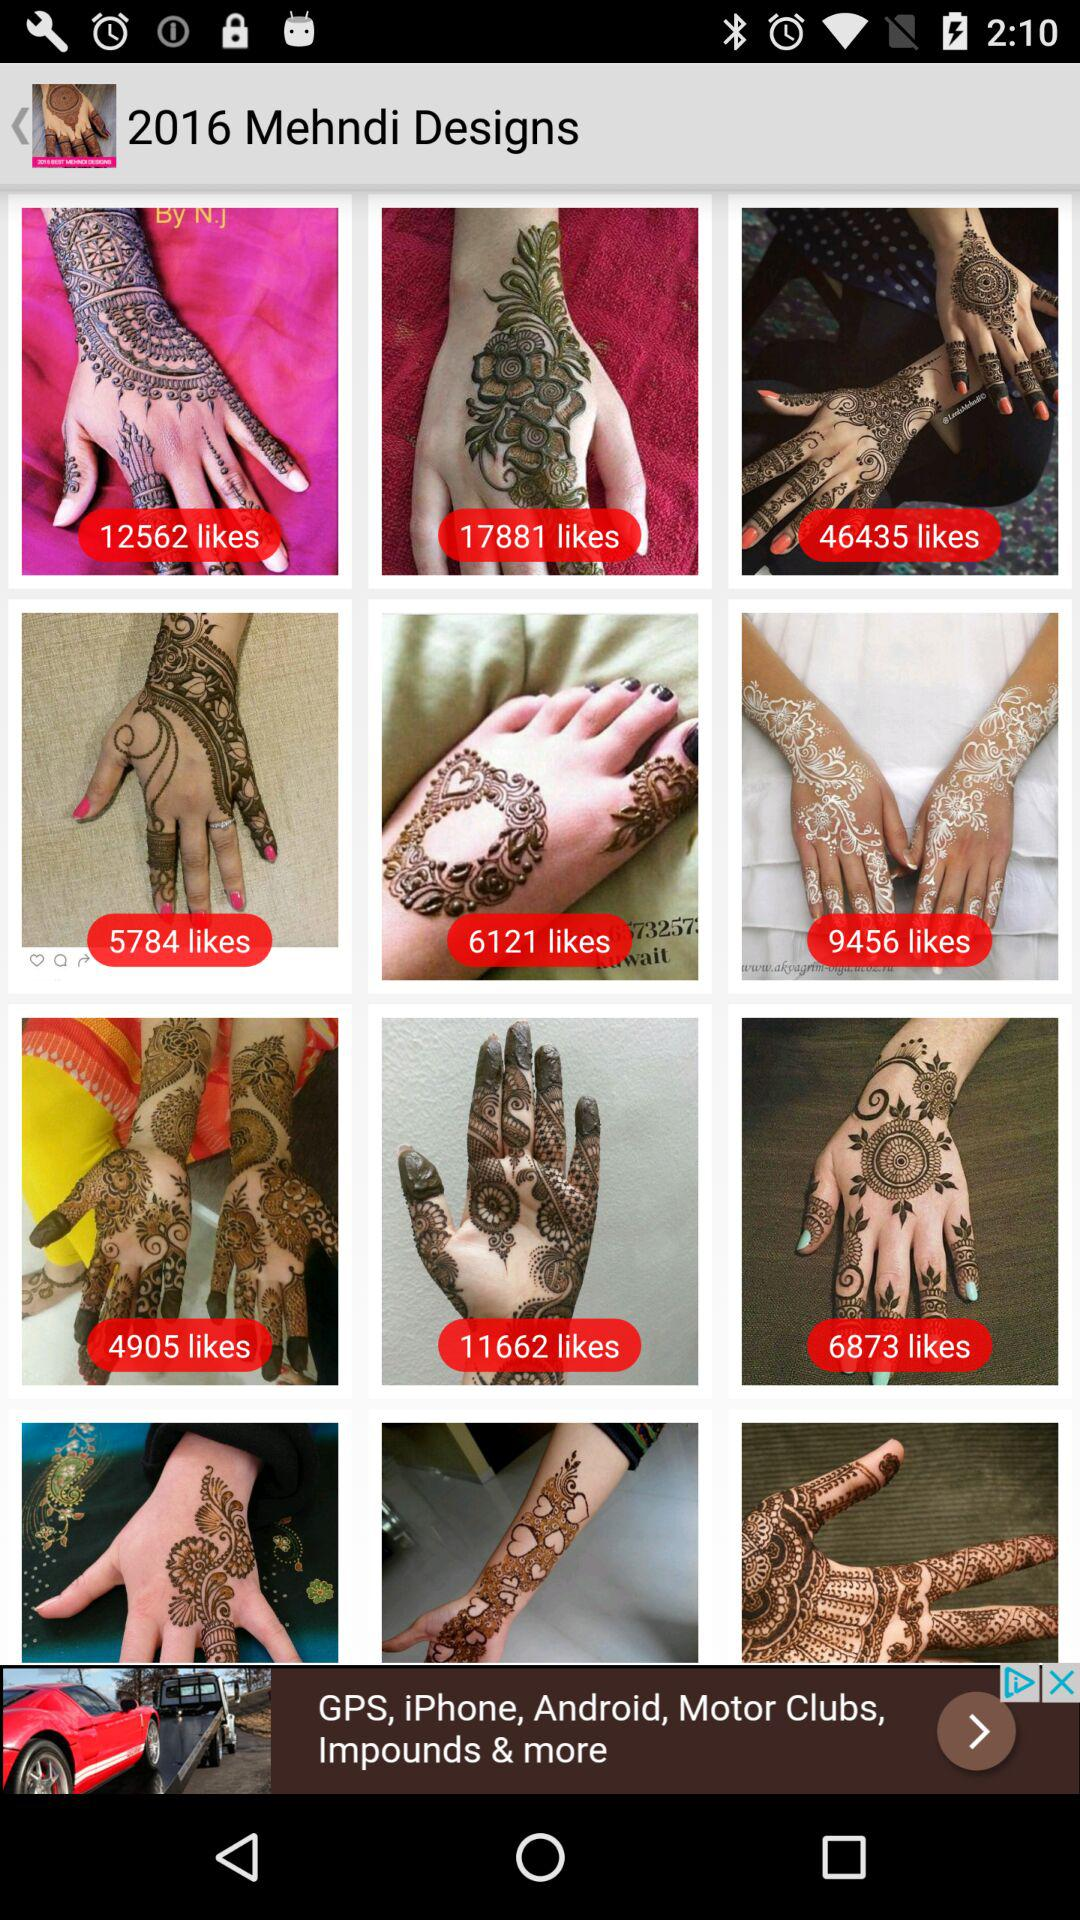What is the application name?
When the provided information is insufficient, respond with <no answer>. <no answer> 